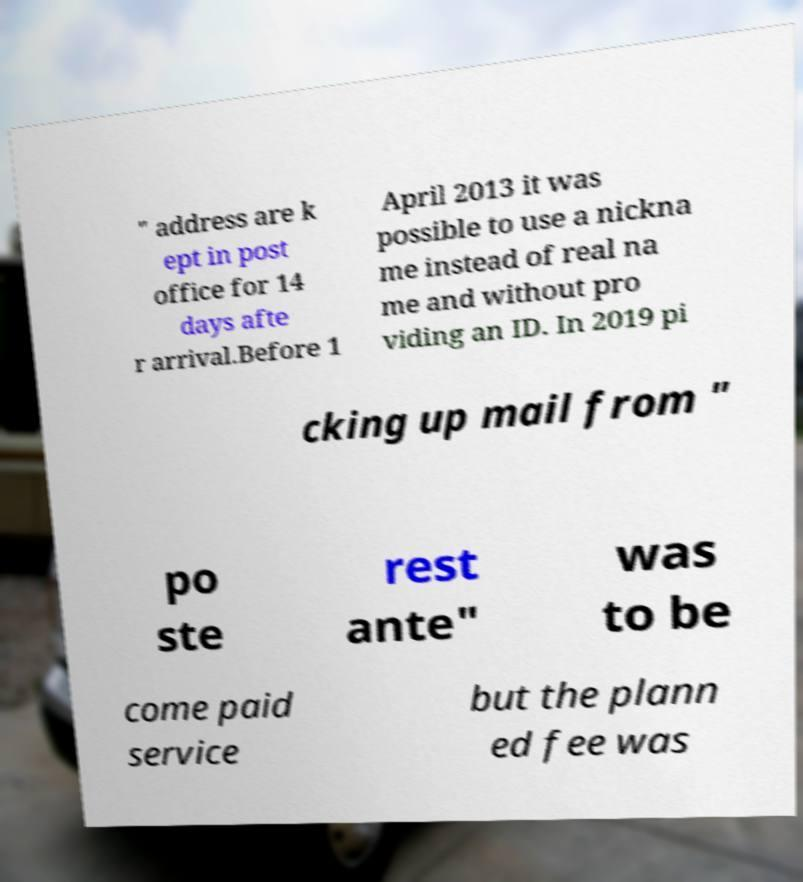For documentation purposes, I need the text within this image transcribed. Could you provide that? " address are k ept in post office for 14 days afte r arrival.Before 1 April 2013 it was possible to use a nickna me instead of real na me and without pro viding an ID. In 2019 pi cking up mail from " po ste rest ante" was to be come paid service but the plann ed fee was 